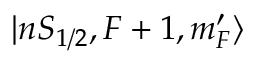Convert formula to latex. <formula><loc_0><loc_0><loc_500><loc_500>| n S _ { 1 / 2 } , F + 1 , m _ { F } ^ { \prime } \rangle</formula> 